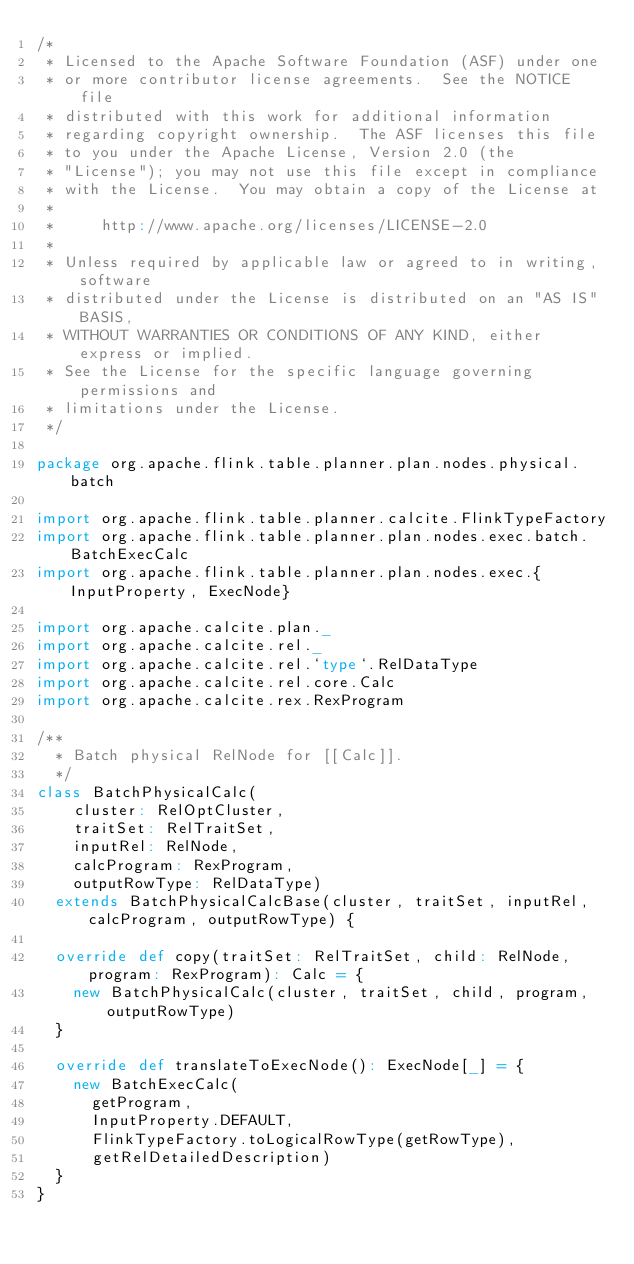<code> <loc_0><loc_0><loc_500><loc_500><_Scala_>/*
 * Licensed to the Apache Software Foundation (ASF) under one
 * or more contributor license agreements.  See the NOTICE file
 * distributed with this work for additional information
 * regarding copyright ownership.  The ASF licenses this file
 * to you under the Apache License, Version 2.0 (the
 * "License"); you may not use this file except in compliance
 * with the License.  You may obtain a copy of the License at
 *
 *     http://www.apache.org/licenses/LICENSE-2.0
 *
 * Unless required by applicable law or agreed to in writing, software
 * distributed under the License is distributed on an "AS IS" BASIS,
 * WITHOUT WARRANTIES OR CONDITIONS OF ANY KIND, either express or implied.
 * See the License for the specific language governing permissions and
 * limitations under the License.
 */

package org.apache.flink.table.planner.plan.nodes.physical.batch

import org.apache.flink.table.planner.calcite.FlinkTypeFactory
import org.apache.flink.table.planner.plan.nodes.exec.batch.BatchExecCalc
import org.apache.flink.table.planner.plan.nodes.exec.{InputProperty, ExecNode}

import org.apache.calcite.plan._
import org.apache.calcite.rel._
import org.apache.calcite.rel.`type`.RelDataType
import org.apache.calcite.rel.core.Calc
import org.apache.calcite.rex.RexProgram

/**
  * Batch physical RelNode for [[Calc]].
  */
class BatchPhysicalCalc(
    cluster: RelOptCluster,
    traitSet: RelTraitSet,
    inputRel: RelNode,
    calcProgram: RexProgram,
    outputRowType: RelDataType)
  extends BatchPhysicalCalcBase(cluster, traitSet, inputRel, calcProgram, outputRowType) {

  override def copy(traitSet: RelTraitSet, child: RelNode, program: RexProgram): Calc = {
    new BatchPhysicalCalc(cluster, traitSet, child, program, outputRowType)
  }

  override def translateToExecNode(): ExecNode[_] = {
    new BatchExecCalc(
      getProgram,
      InputProperty.DEFAULT,
      FlinkTypeFactory.toLogicalRowType(getRowType),
      getRelDetailedDescription)
  }
}
</code> 